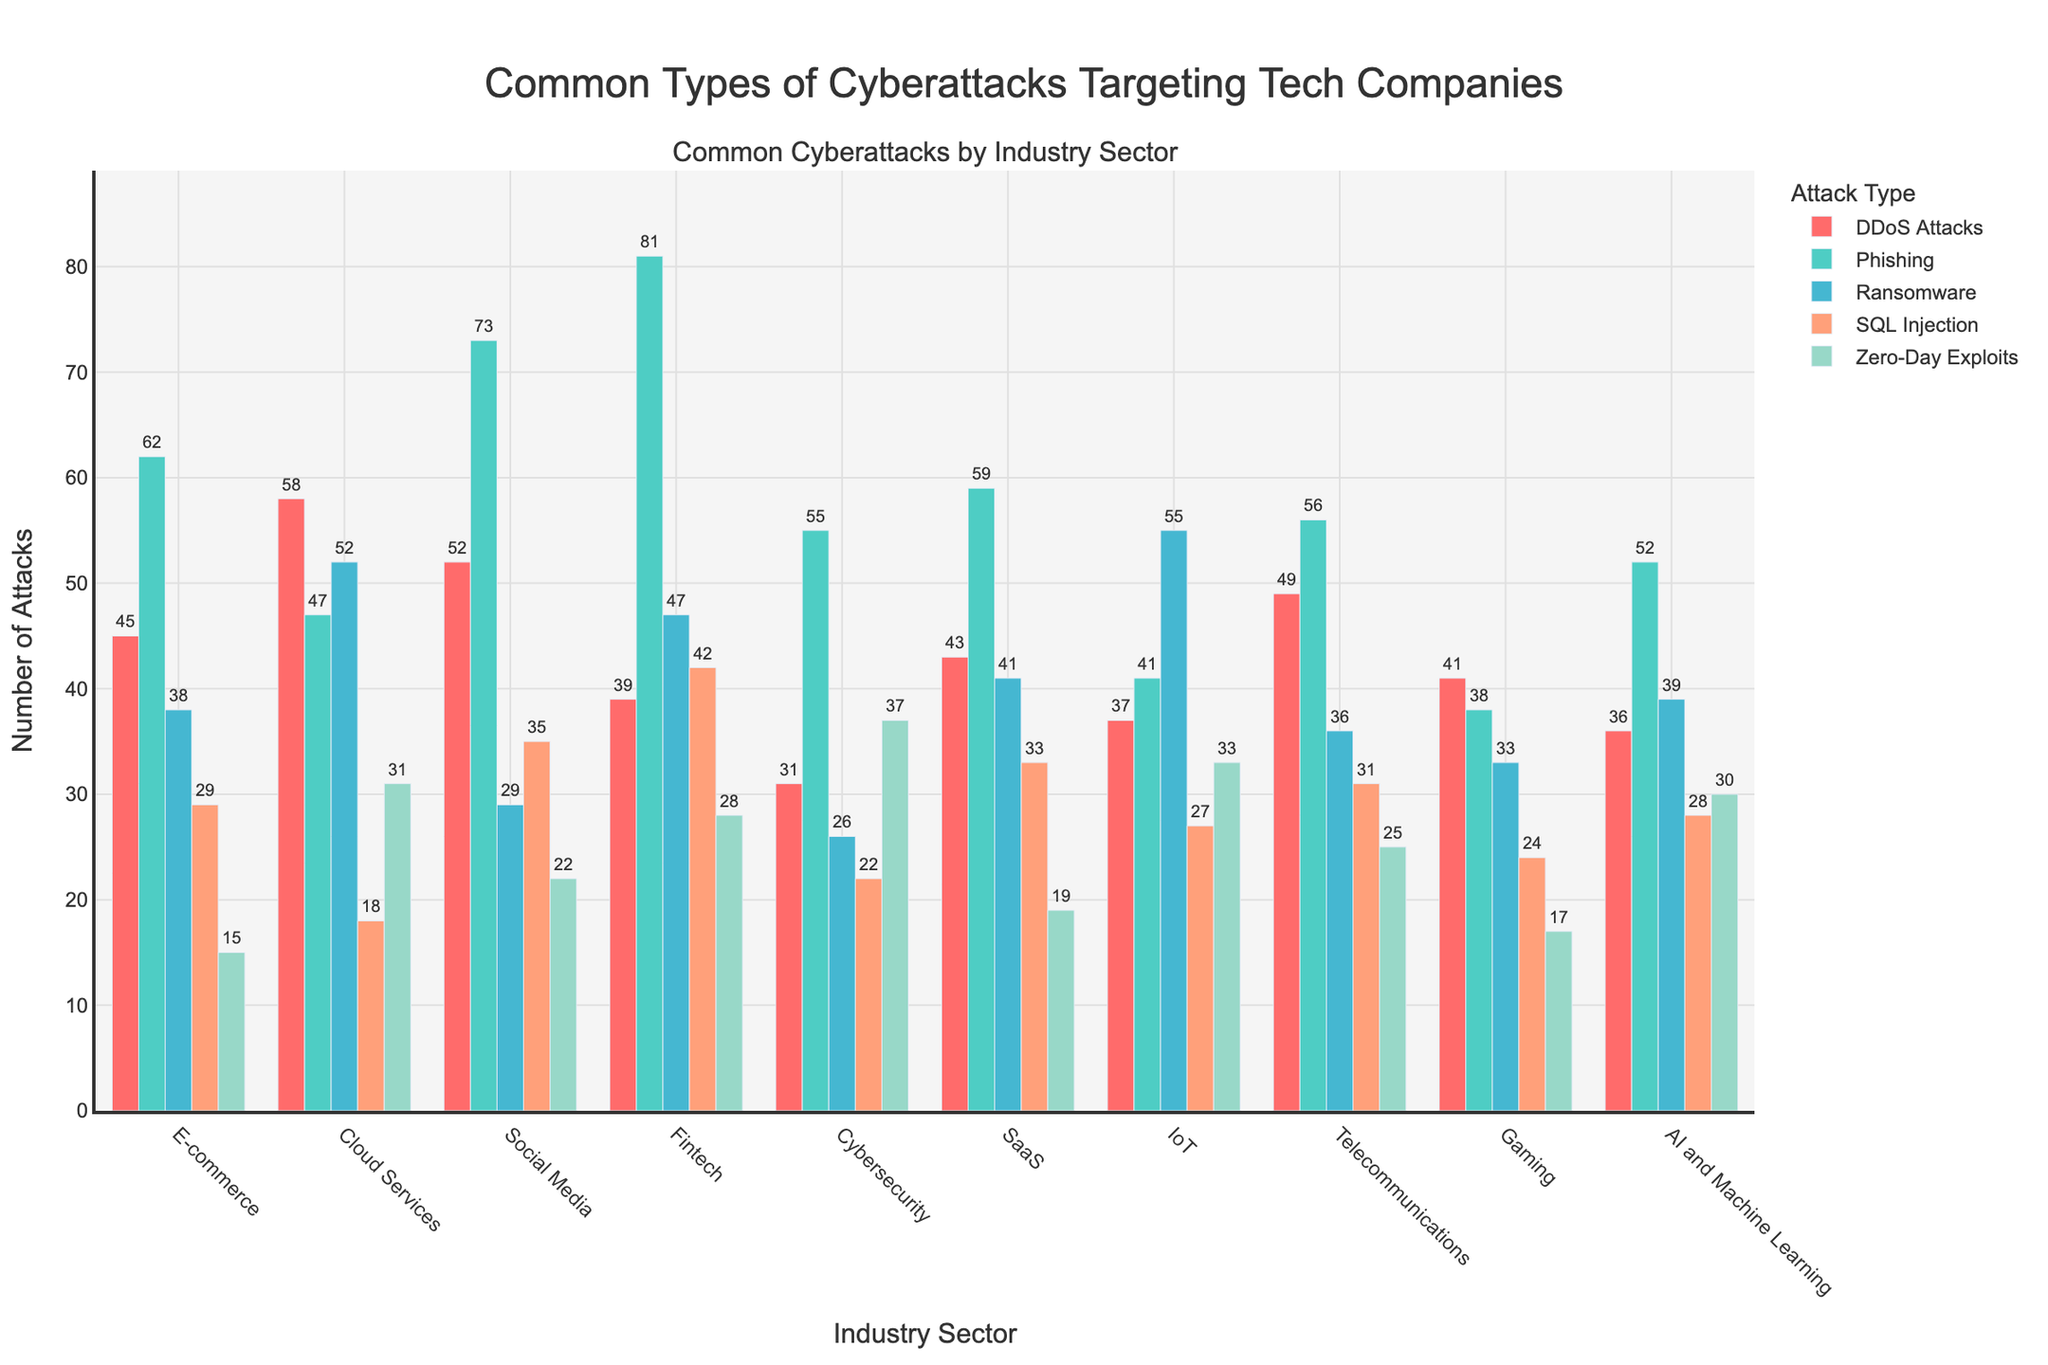Which industry sector experiences the highest number of phishing attacks? The sector with the highest bar for phishing attacks will have the greatest number in this category. From the figure, Fintech has the highest bar for phishing attacks.
Answer: Fintech Which two industry sectors suffer the most from DDoS attacks combined? Add the DDoS attacks for each sector to find the two with the highest combined total. Cloud Services and Social Media have 58 and 52 attacks respectively, making them the highest combined total.
Answer: Cloud Services and Social Media What is the range of ransomware attacks across all industry sectors? Identify the smallest and largest number of ransomware attacks and calculate the difference. The smallest is Cybersecurity with 26 attacks, and the largest is Cloud Services with 52, giving a range of 52 - 26 = 26.
Answer: 26 Which attack type has the most occurrences in the E-commerce sector, and how many occurrences are there? Find the highest bar for the E-commerce sector. Phishing has the most occurrences with 62 attacks in this sector.
Answer: Phishing with 62 occurrences Compare the number of Zero-Day Exploits in IoT and Social Media sectors. Which is greater? Compare the height of the Zero-Day Exploits bars for IoT and Social Media. IoT has 33 attacks, while Social Media has 22, making IoT greater.
Answer: IoT How many more phishing attacks does the Fintech sector have compared to the E-commerce sector? Subtract the number of phishing attacks in E-commerce from the number in Fintech. Fintech has 81, and E-commerce has 62, resulting in 81 - 62 = 19 more attacks.
Answer: 19 What is the average number of SQL Injection attacks across all the listed industry sectors? Sum the number of SQL Injection attacks and divide by the number of sectors. Summing up the SQL Injection attacks: 29 + 18 + 35 + 42 + 22 + 33 + 27 + 31 + 24 + 28 = 289. There are 10 sectors, so the average is 289 / 10 = 28.9.
Answer: 28.9 Which three industry sectors have the smallest number of Zero-Day Exploits? Find the three smallest numbers in the Zero-Day Exploits column. They are E-commerce (15), SaaS (19), and Gaming (17).
Answer: E-commerce, SaaS, and Gaming Is the total number of ransomware attacks greater in AI and Machine Learning than in Gaming and SaaS combined? First, sum the ransomware attacks in Gaming and SaaS, then compare it to AI and Machine Learning. Gaming has 33, SaaS has 41, and AI and Machine Learning has 39. So, 33 + 41 = 74, which is greater than 39.
Answer: No Which industry sector shows the highest variability in the number of different attack types? Find the sector that has the biggest range between the highest and lowest number of attacks across all types. Fintech shows high variability with a range from 28 to 81, higher than other sectors.
Answer: Fintech 